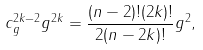<formula> <loc_0><loc_0><loc_500><loc_500>c ^ { 2 k - 2 } _ { g } g ^ { 2 k } = \frac { ( n - 2 ) ! ( 2 k ) ! } { 2 ( n - 2 k ) ! } g ^ { 2 } ,</formula> 